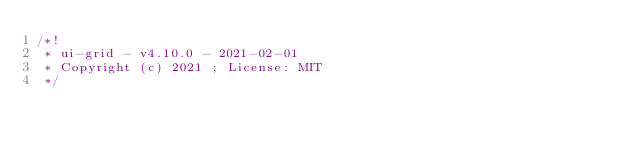<code> <loc_0><loc_0><loc_500><loc_500><_JavaScript_>/*!
 * ui-grid - v4.10.0 - 2021-02-01
 * Copyright (c) 2021 ; License: MIT 
 */

</code> 